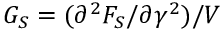Convert formula to latex. <formula><loc_0><loc_0><loc_500><loc_500>G _ { S } = ( \partial ^ { 2 } F _ { S } / \partial \gamma ^ { 2 } ) / V</formula> 